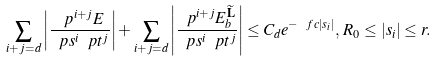Convert formula to latex. <formula><loc_0><loc_0><loc_500><loc_500>\sum _ { i + j = d } \left | \frac { \ p ^ { i + j } E } { \ p s ^ { i } \ p t ^ { j } } \right | + \sum _ { i + j = d } \left | \frac { \ p ^ { i + j } E _ { b } ^ { \widetilde { \mathbf L } } } { \ p s ^ { i } \ p t ^ { j } } \right | \leq C _ { d } e ^ { - \ f c | s _ { i } | } , \, R _ { 0 } \leq | s _ { i } | \leq r .</formula> 